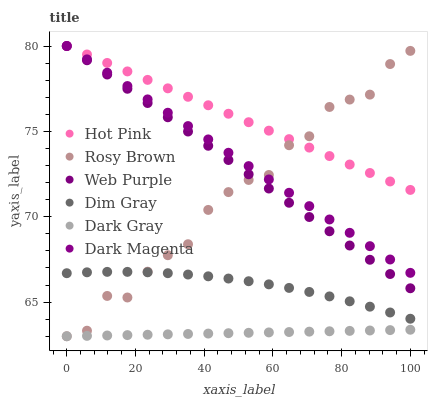Does Dark Gray have the minimum area under the curve?
Answer yes or no. Yes. Does Hot Pink have the maximum area under the curve?
Answer yes or no. Yes. Does Dark Magenta have the minimum area under the curve?
Answer yes or no. No. Does Dark Magenta have the maximum area under the curve?
Answer yes or no. No. Is Dark Gray the smoothest?
Answer yes or no. Yes. Is Rosy Brown the roughest?
Answer yes or no. Yes. Is Dark Magenta the smoothest?
Answer yes or no. No. Is Dark Magenta the roughest?
Answer yes or no. No. Does Rosy Brown have the lowest value?
Answer yes or no. Yes. Does Dark Magenta have the lowest value?
Answer yes or no. No. Does Web Purple have the highest value?
Answer yes or no. Yes. Does Rosy Brown have the highest value?
Answer yes or no. No. Is Dim Gray less than Dark Magenta?
Answer yes or no. Yes. Is Hot Pink greater than Dim Gray?
Answer yes or no. Yes. Does Rosy Brown intersect Web Purple?
Answer yes or no. Yes. Is Rosy Brown less than Web Purple?
Answer yes or no. No. Is Rosy Brown greater than Web Purple?
Answer yes or no. No. Does Dim Gray intersect Dark Magenta?
Answer yes or no. No. 